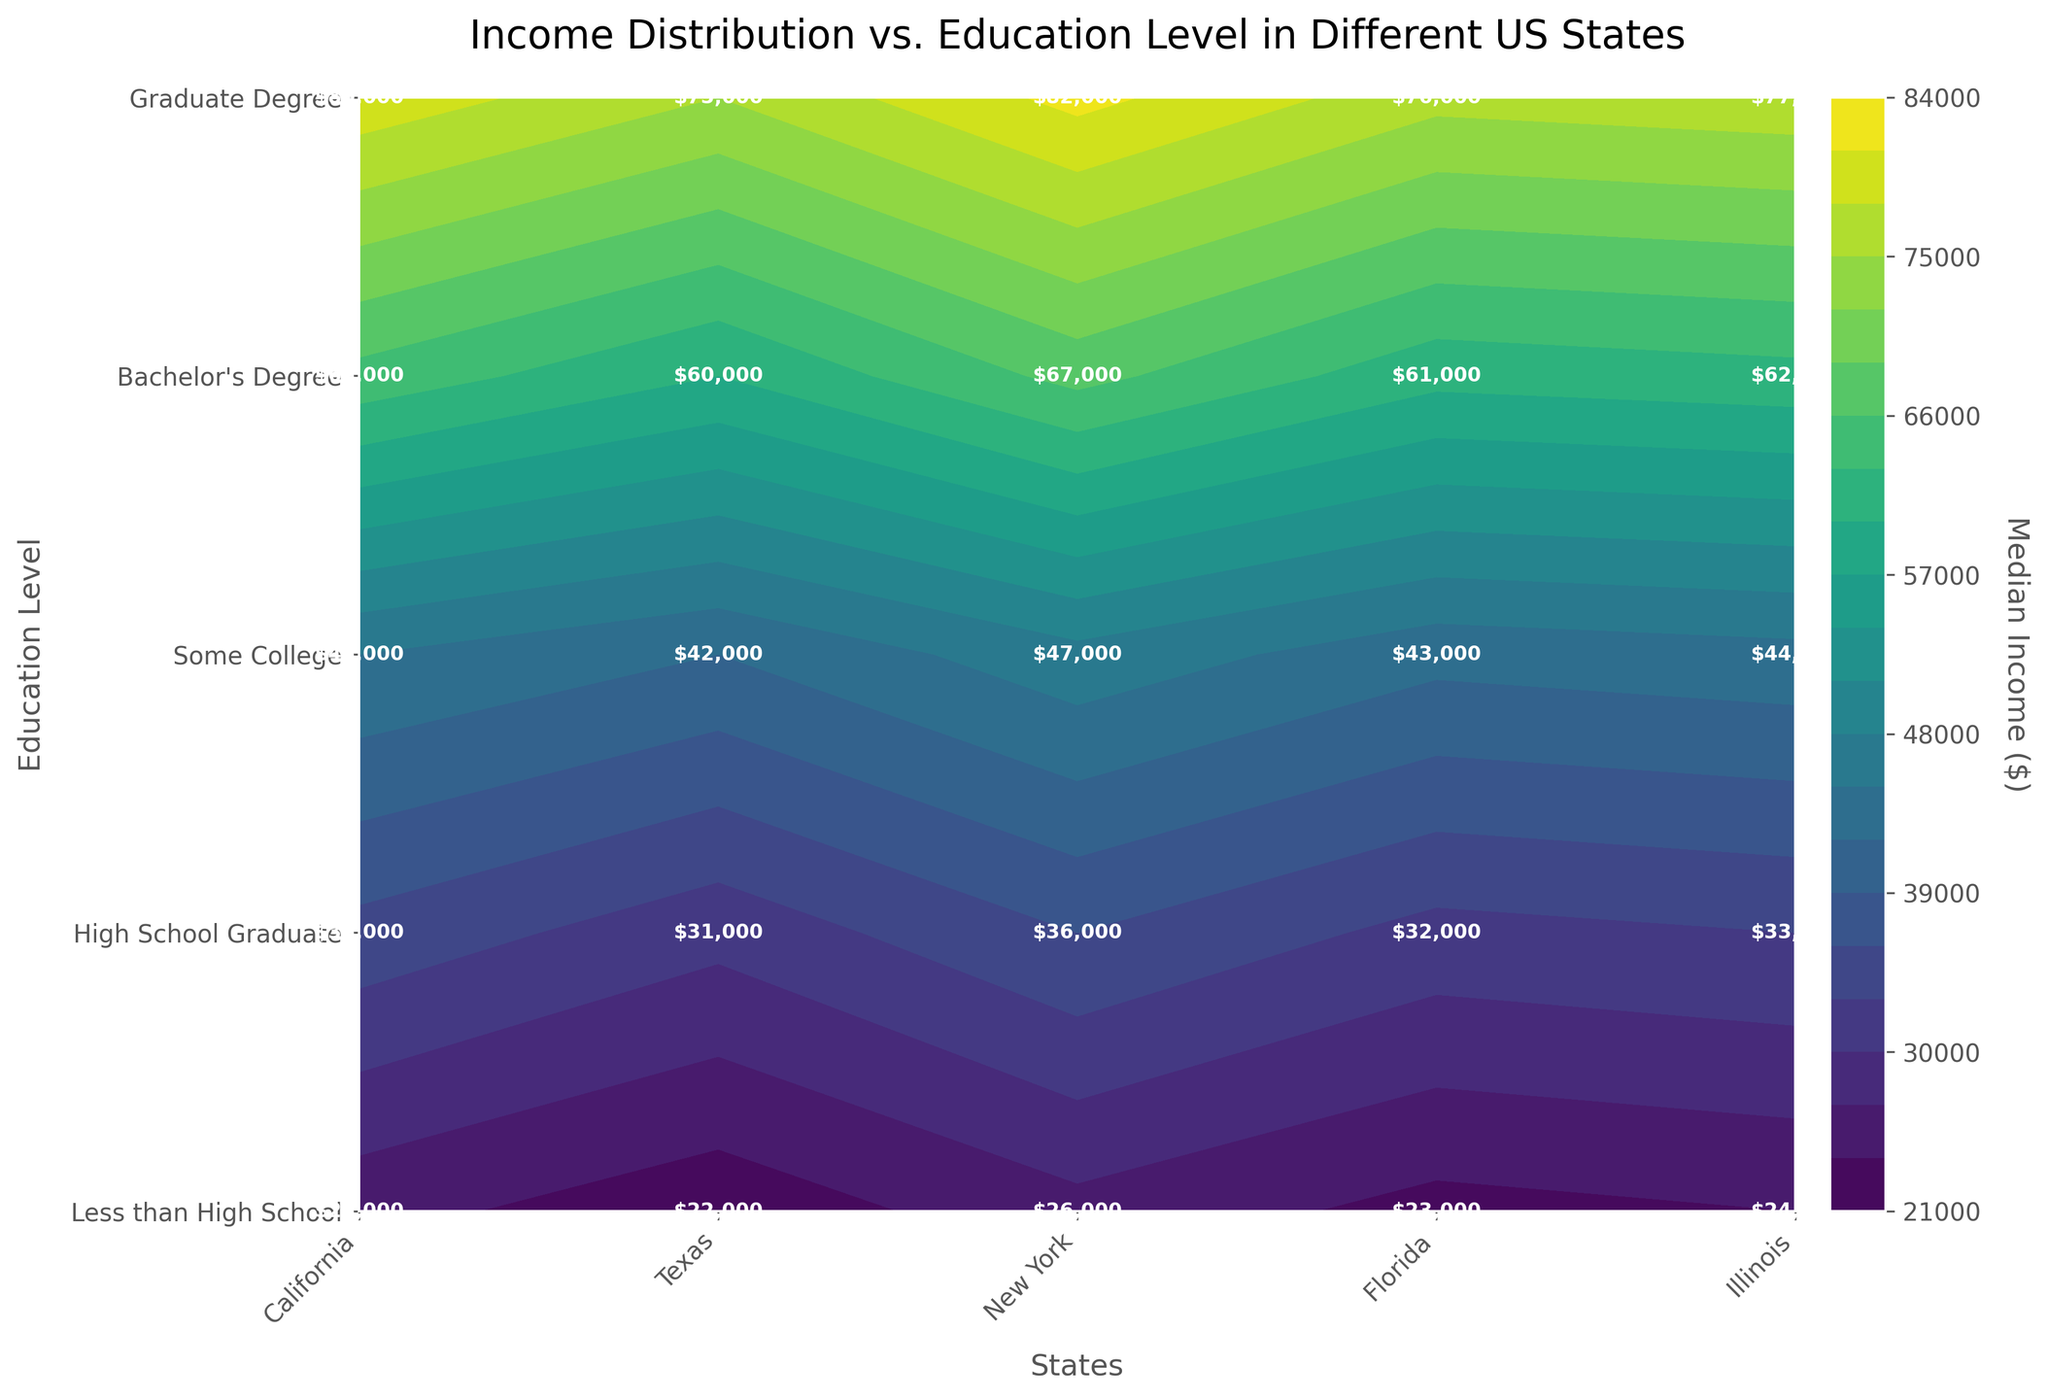What is the title of the figure? The title is usually located at the top of the figure. Look for a phrase in larger or bold text that summarizes the content of the plot.
Answer: Income Distribution vs. Education Level in Different US States How are the states arranged along the x-axis? The x-axis labels represent different states and they are usually listed sequentially. In this figure, the states appear from left to right: California, Texas, New York, Florida, Illinois.
Answer: California, Texas, New York, Florida, Illinois Which state has the highest median income for those with a Graduate Degree? Look for the highest value shown on the plot at the level corresponding to "Graduate Degree" for each state. The state with the highest labeled value is the answer.
Answer: New York What is the median income for High School Graduates in Illinois? Locate Illinois along the x-axis and then move vertically to the level corresponding to "High School Graduate." The labeled value at this intersection is the median income.
Answer: $33,000 Which education level generally shows the highest median income across all states? Move your eyes horizontally across the different education levels and compare the general trend of the labeled values. The education level with the consistently highest values across states will be the answer.
Answer: Graduate Degree Is the median income for those with a Bachelor's Degree in California higher or lower than in Florida? Identify the labeled values for "Bachelor's Degree" in both California and Florida. Compare the two values.
Answer: Higher What is the difference in median income between High School Graduates and those with Some College education in Texas? Locate Texas on the x-axis and find the labeled values for "High School Graduate" and "Some College." Subtract the High School Graduate value from the Some College value.
Answer: $11,000 Which state has the smallest range of median incomes across different education levels? For each state, find the difference between the highest and lowest median incomes shown. The state with the smallest difference is the answer.
Answer: Texas In which state do people with "Less than High School" education earn more than $25,000? Examine the labeled values on the plot at the "Less than High School" level for each state. Identify the states where the value is greater than $25,000.
Answer: New York What education level has the lowest median income in Florida? Locate Florida on the x-axis and identify the labeled value for each education level. Find the education level with the lowest labeled value within Florida.
Answer: Less than High School 